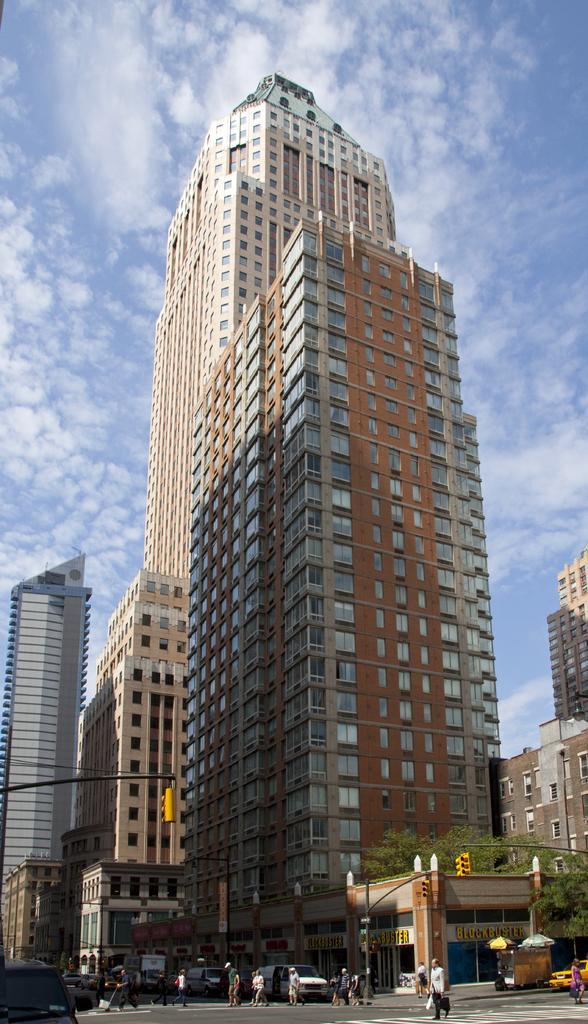In one or two sentences, can you explain what this image depicts? In this image in the center there are persons walking and there are vehicles on the road and in the background there are buildings and the sky is cloudy. 